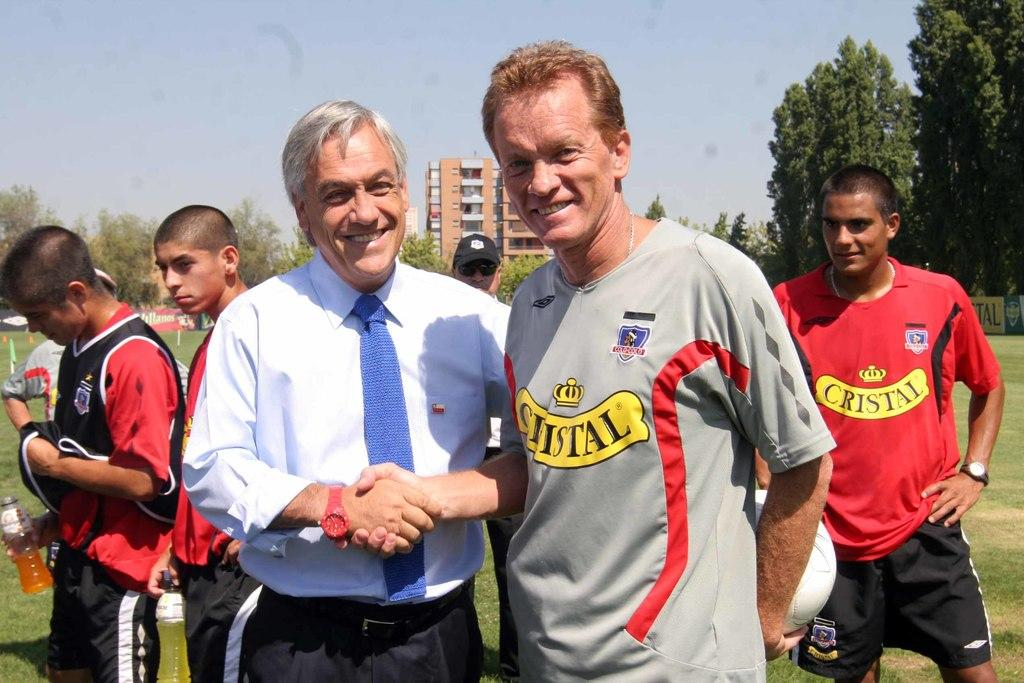What are the two persons in the image doing? The two persons in the image are standing and shaking hands. Are there any other people present in the image? Yes, there are people standing behind them. What can be seen in the background of the image? There are trees and buildings in the background of the image. What type of iron is being used by the person on the left in the image? There is no iron present in the image; the two persons are shaking hands. 